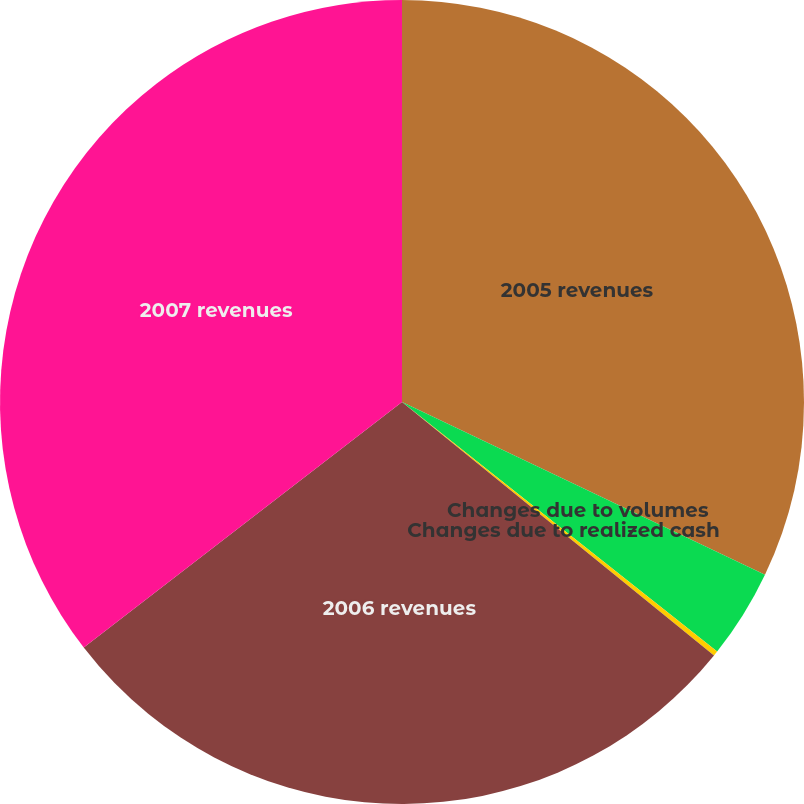Convert chart. <chart><loc_0><loc_0><loc_500><loc_500><pie_chart><fcel>2005 revenues<fcel>Changes due to volumes<fcel>Changes due to realized cash<fcel>2006 revenues<fcel>2007 revenues<nl><fcel>32.07%<fcel>3.59%<fcel>0.2%<fcel>28.68%<fcel>35.46%<nl></chart> 